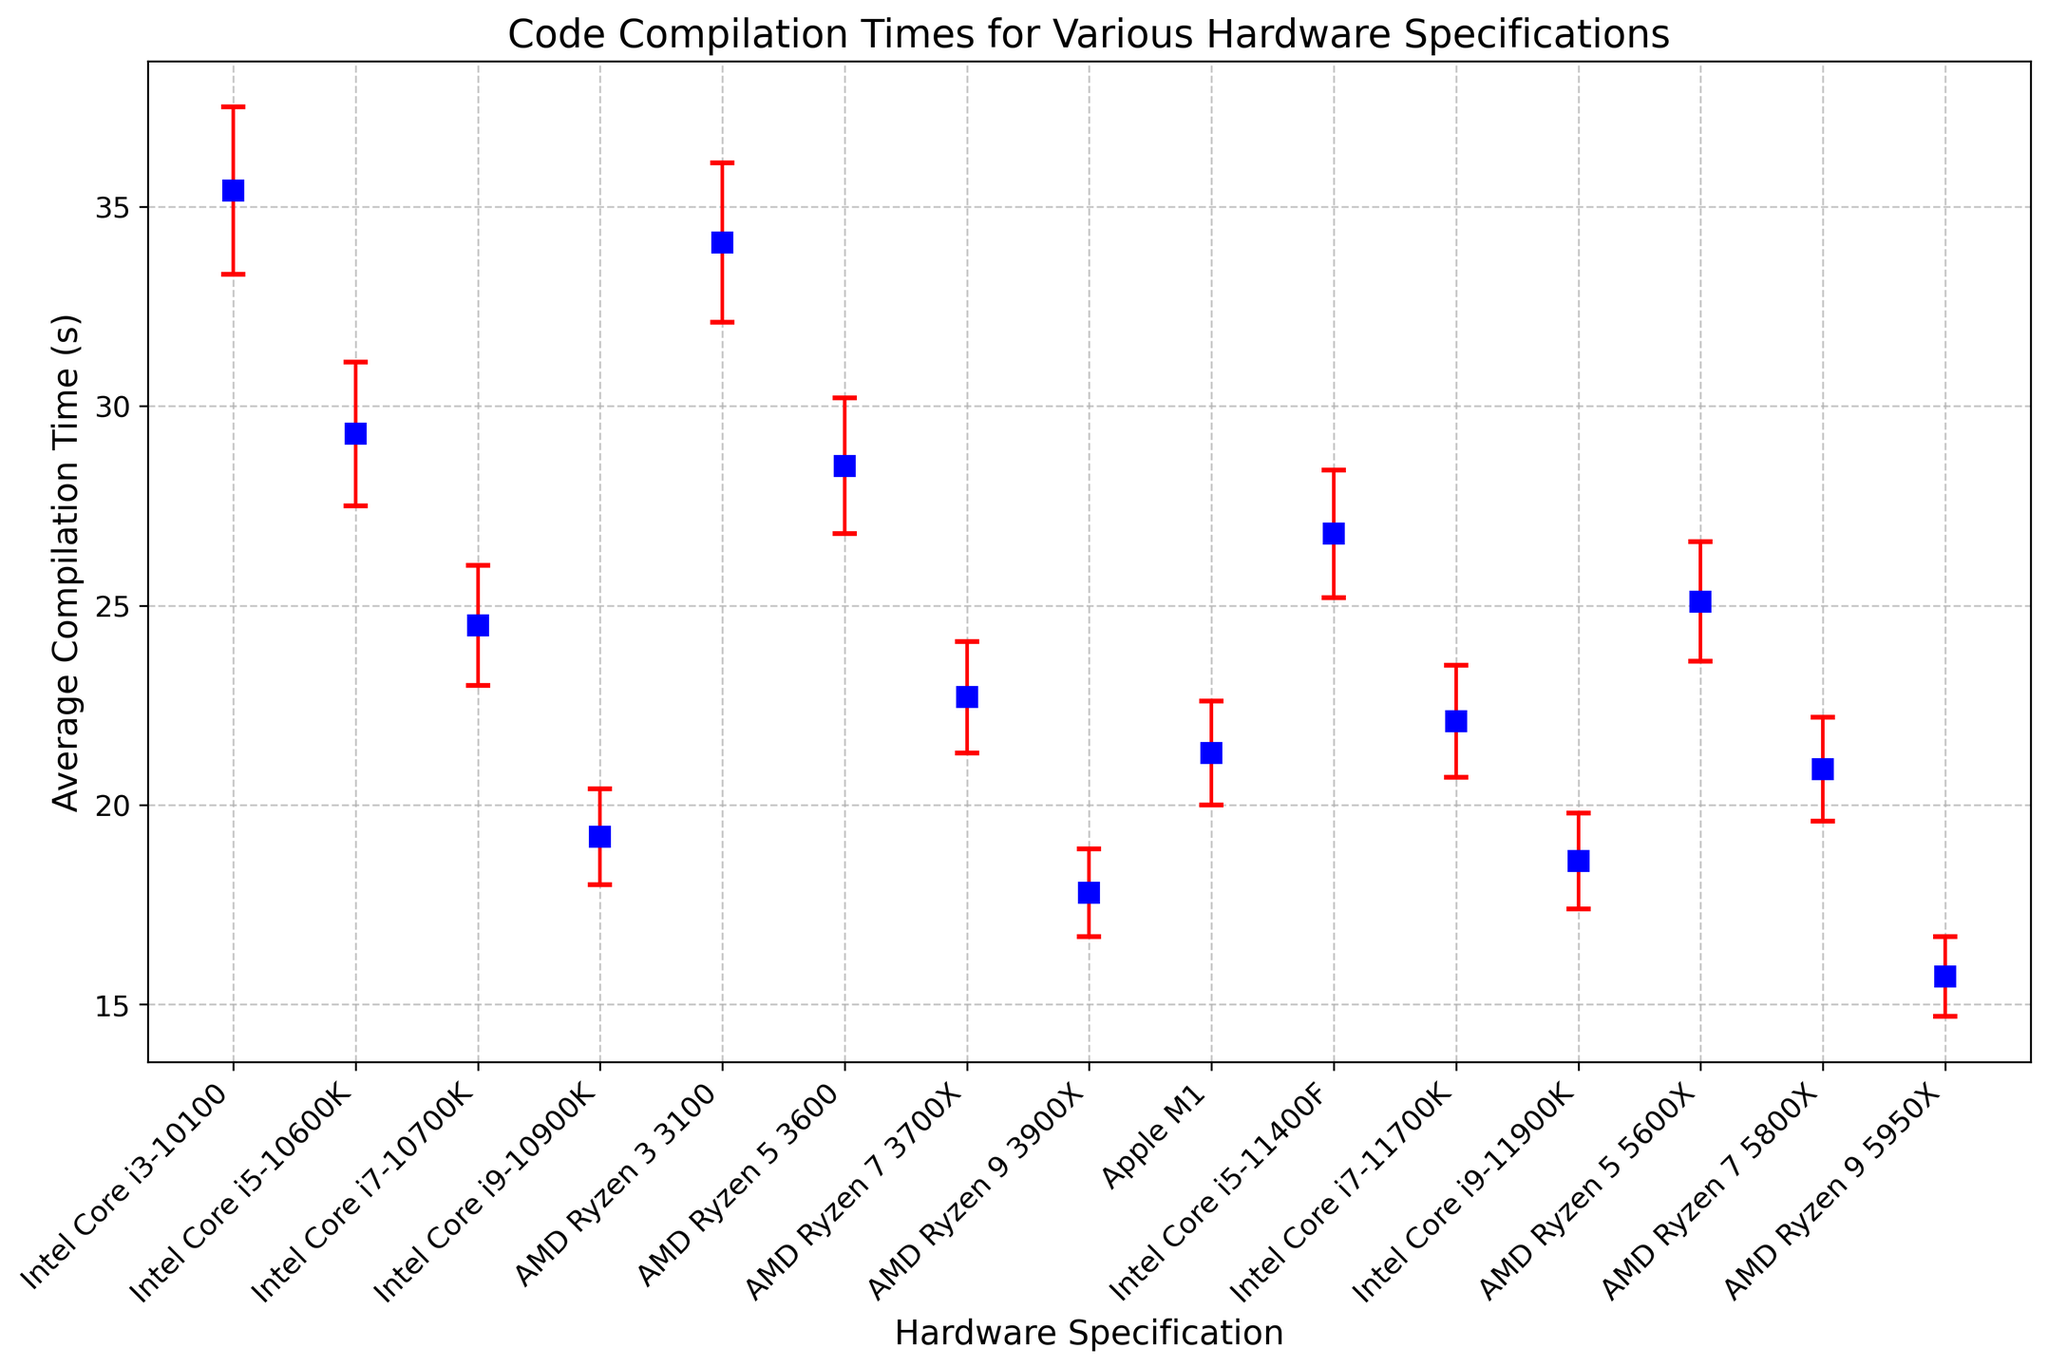Which hardware specification has the shortest average compilation time? The graph shows the average compilation times for different hardware specifications. By examining the graph, the shortest average compilation time is for "AMD Ryzen 9 5950X" with 15.7 seconds.
Answer: AMD Ryzen 9 5950X Which hardware specification has the longest average compilation time? By looking at the graph, we can see that the "Intel Core i3-10100" has the longest average compilation time at 35.4 seconds.
Answer: Intel Core i3-10100 What is the difference in average compilation time between "Intel Core i9-10900K" and "AMD Ryzen 9 3900X"? The average compilation time for "Intel Core i9-10900K" is 19.2 seconds, and for "AMD Ryzen 9 3900X" it is 17.8 seconds. The difference is 19.2 - 17.8 = 1.4 seconds.
Answer: 1.4 seconds Which hardware specification has the largest standard deviation in compilation time? The graph shows error bars representing the standard deviations. The "Intel Core i3-10100" has the largest standard deviation at 2.1 seconds.
Answer: Intel Core i3-10100 Which hardware specification has a lower average compilation time: "Intel Core i5-10600K" or "AMD Ryzen 5 3600"? Comparing the average compilation times from the graph, "Intel Core i5-10600K" has an average time of 29.3 seconds, and "AMD Ryzen 5 3600" has 28.5 seconds. "AMD Ryzen 5 3600" has a lower average compilation time.
Answer: AMD Ryzen 5 3600 What's the combined average compilation time for all Intel Core i7 processors presented? The Intel Core i7 processors listed are "Intel Core i7-10700K" (24.5s), "Intel Core i7-11700K" (22.1s). To find the combined average, sum these and divide by the number of processors: (24.5 + 22.1)/2 = 23.3 seconds.
Answer: 23.3 seconds Calculate the average of the standard deviations for AMD Ryzen processors. The standard deviations for AMD Ryzen processors are 2.0, 1.7, 1.4, 1.1, 1.5, 1.3, 1.0. To find the average, sum these values up: 2.0 + 1.7 + 1.4 + 1.1 + 1.5 + 1.3 + 1.0 = 10.0. Then divide by the number of processors: 10.0/7 = 1.43 seconds.
Answer: 1.43 seconds Which hardware specification's data point is closest to the average compilation time among all listed hardware specifications? Calculate the average compilation time across all hardware specifications. Sum all the average times and divide by the number of hardware specs: (35.4+29.3+24.5+19.2+34.1+28.5+22.7+17.8+21.3+26.8+22.1+18.6+25.1+20.9+15.7)/15 ≈ 24.47 seconds. The closest data point to this value is "AMD Ryzen 7 3700X" with 22.7 seconds.
Answer: AMD Ryzen 7 3700X 